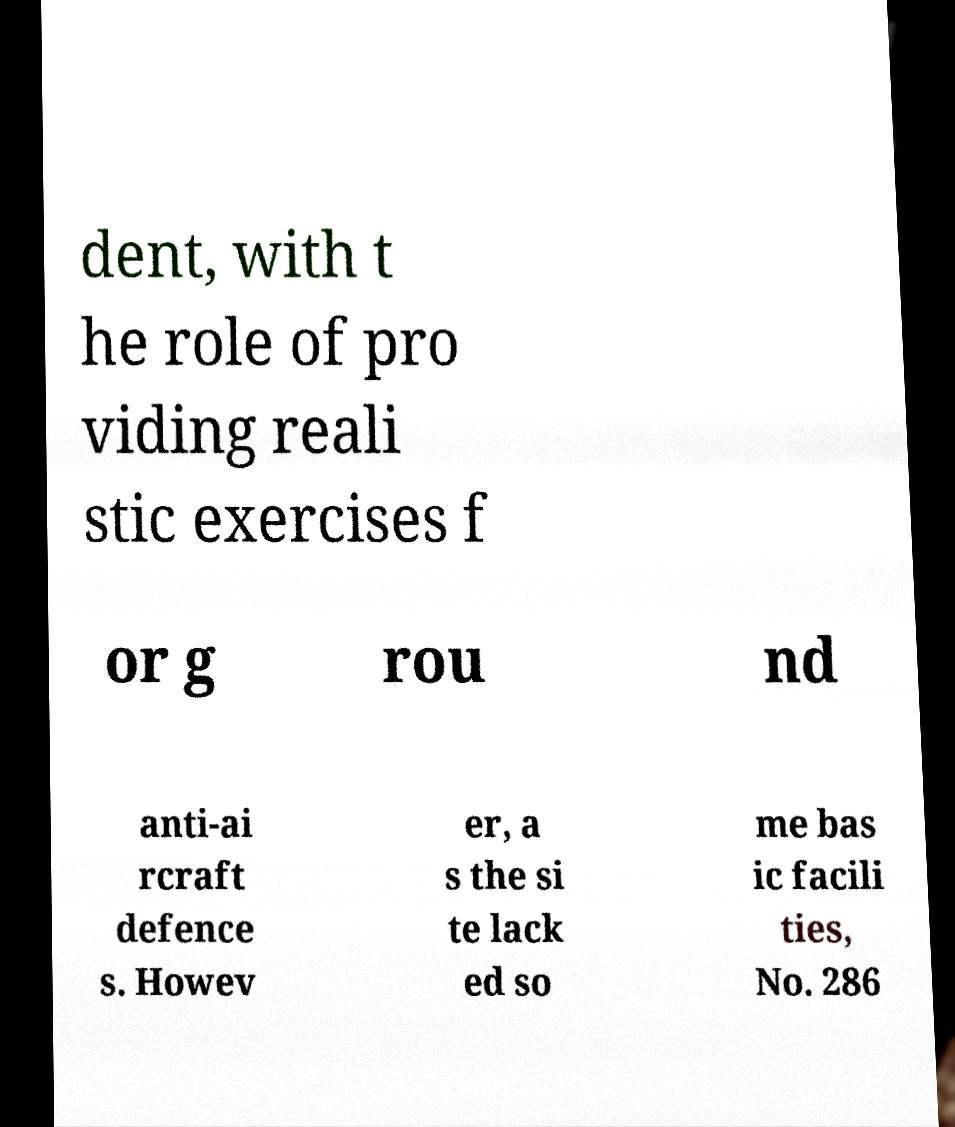Can you read and provide the text displayed in the image?This photo seems to have some interesting text. Can you extract and type it out for me? dent, with t he role of pro viding reali stic exercises f or g rou nd anti-ai rcraft defence s. Howev er, a s the si te lack ed so me bas ic facili ties, No. 286 